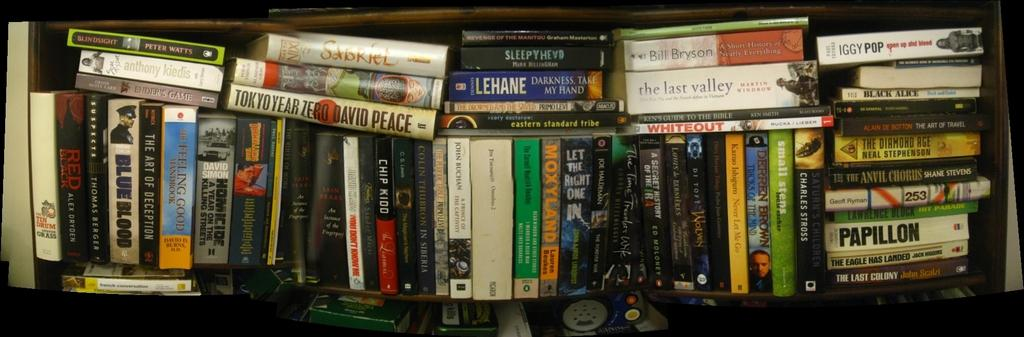<image>
Provide a brief description of the given image. Books on a shelve that has a book with black lettering Papillion 